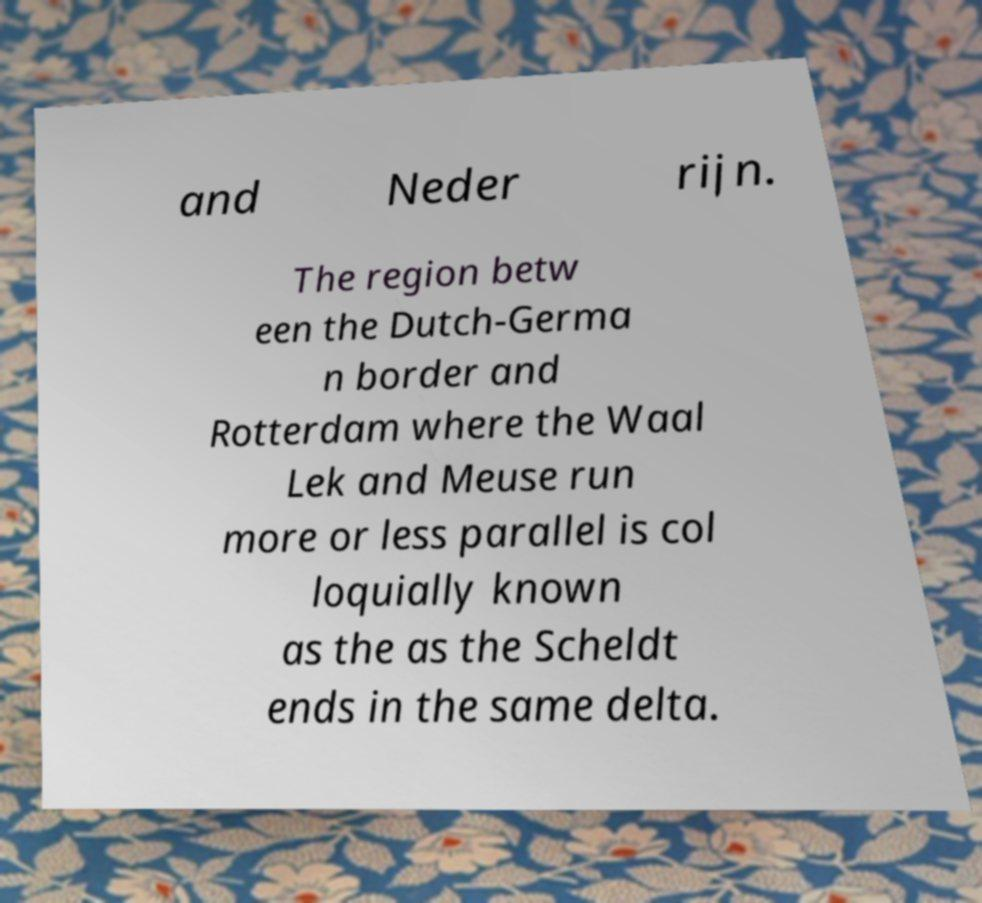For documentation purposes, I need the text within this image transcribed. Could you provide that? and Neder rijn. The region betw een the Dutch-Germa n border and Rotterdam where the Waal Lek and Meuse run more or less parallel is col loquially known as the as the Scheldt ends in the same delta. 